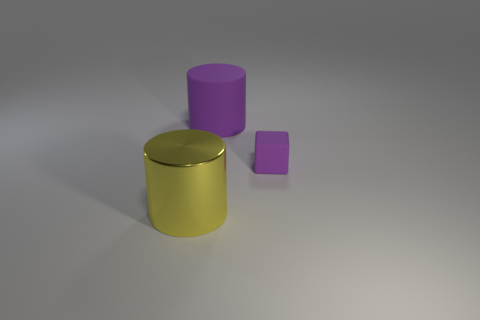Add 1 small purple objects. How many objects exist? 4 Subtract all cylinders. How many objects are left? 1 Subtract 0 green balls. How many objects are left? 3 Subtract all objects. Subtract all large blue metal spheres. How many objects are left? 0 Add 1 matte cubes. How many matte cubes are left? 2 Add 3 small gray shiny blocks. How many small gray shiny blocks exist? 3 